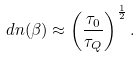Convert formula to latex. <formula><loc_0><loc_0><loc_500><loc_500>d n ( \beta ) \approx \left ( \frac { \tau _ { 0 } } { \tau _ { Q } } \right ) ^ { \frac { 1 } { 2 } } .</formula> 